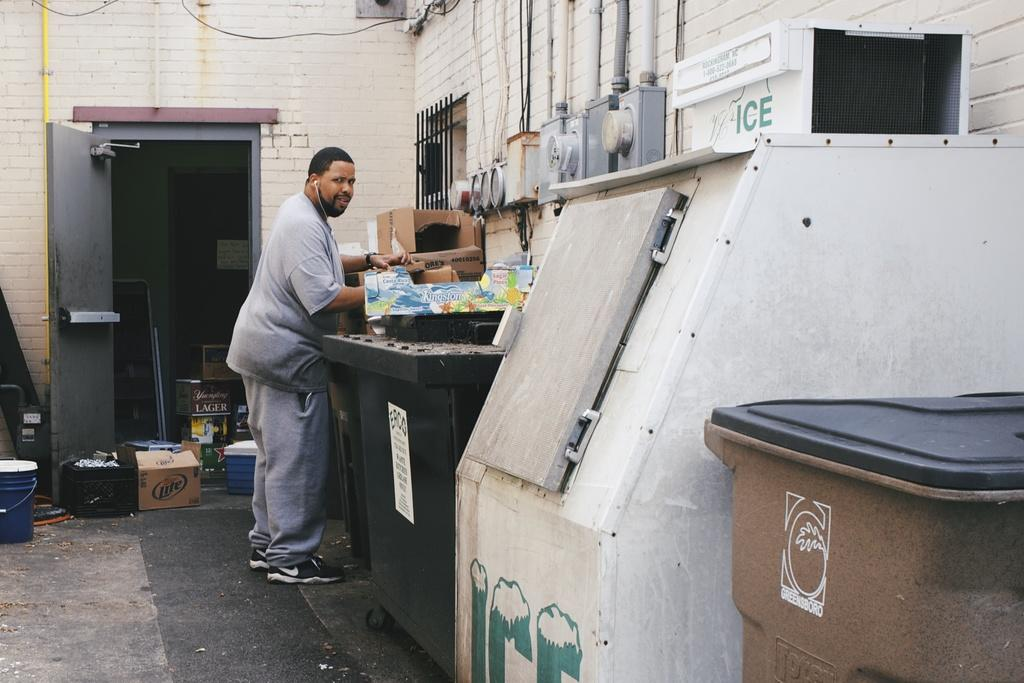<image>
Render a clear and concise summary of the photo. An Ice machine with the word "ice" at the top sits outdoors. 